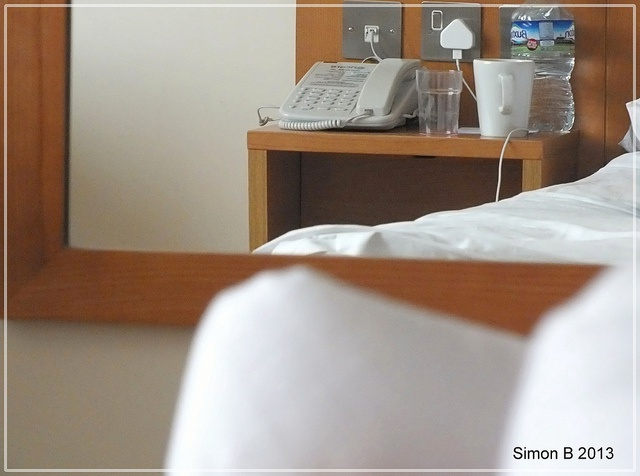Describe the objects in this image and their specific colors. I can see bed in brown, lightgray, darkgray, and gray tones, bed in brown, lightgray, darkgray, and black tones, bottle in brown, gray, and darkgray tones, cup in brown, darkgray, lightgray, and gray tones, and cup in brown, gray, and darkgray tones in this image. 